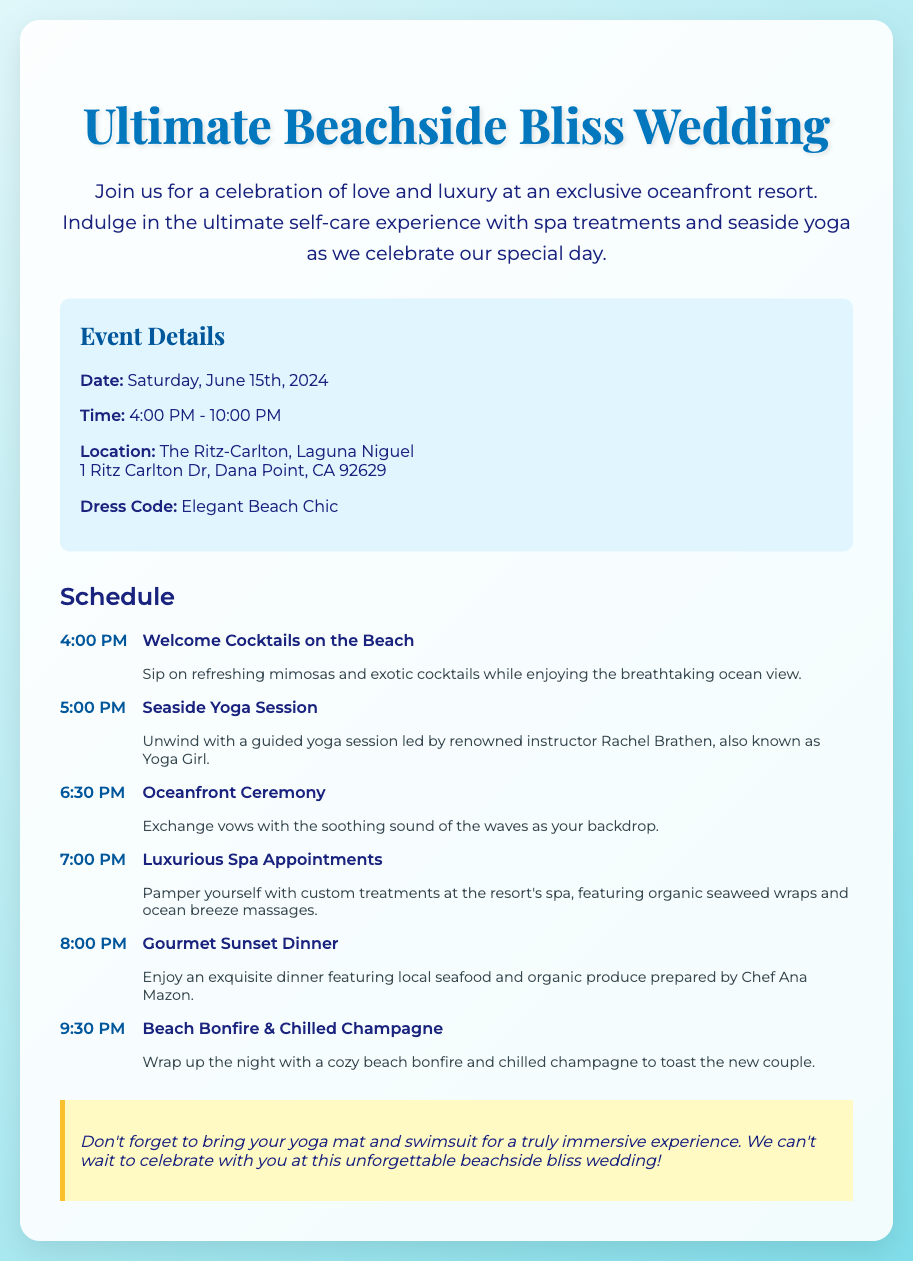What is the date of the wedding? The wedding is scheduled for Saturday, June 15th, 2024.
Answer: June 15th, 2024 What time does the welcome cocktails begin? The welcome cocktails start at 4:00 PM.
Answer: 4:00 PM Where is the wedding location? The location of the wedding is The Ritz-Carlton, Laguna Niguel.
Answer: The Ritz-Carlton, Laguna Niguel Who is leading the seaside yoga session? The seaside yoga session is led by renowned instructor Rachel Brathen, also known as Yoga Girl.
Answer: Rachel Brathen What is the dress code for the wedding? The dress code specified for the wedding is Elegant Beach Chic.
Answer: Elegant Beach Chic What is served during the beach bonfire? Chilled champagne is served during the beach bonfire.
Answer: Chilled champagne How much time is scheduled for luxurious spa appointments? The luxurious spa appointments are scheduled for 7:00 PM.
Answer: 7:00 PM What should guests bring for the yoga session? Guests are advised to bring their yoga mat and swimsuit for the yoga session.
Answer: Yoga mat and swimsuit 